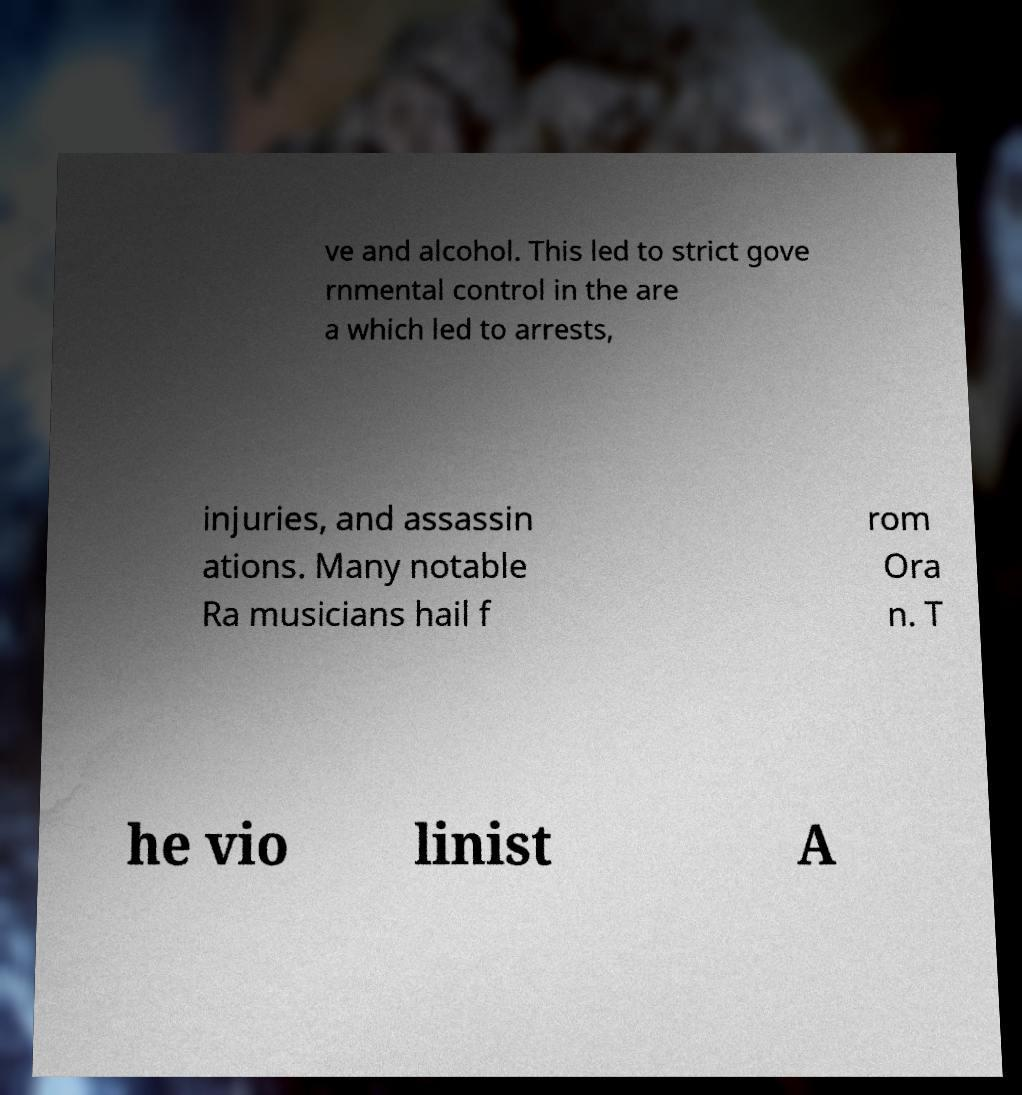I need the written content from this picture converted into text. Can you do that? ve and alcohol. This led to strict gove rnmental control in the are a which led to arrests, injuries, and assassin ations. Many notable Ra musicians hail f rom Ora n. T he vio linist A 